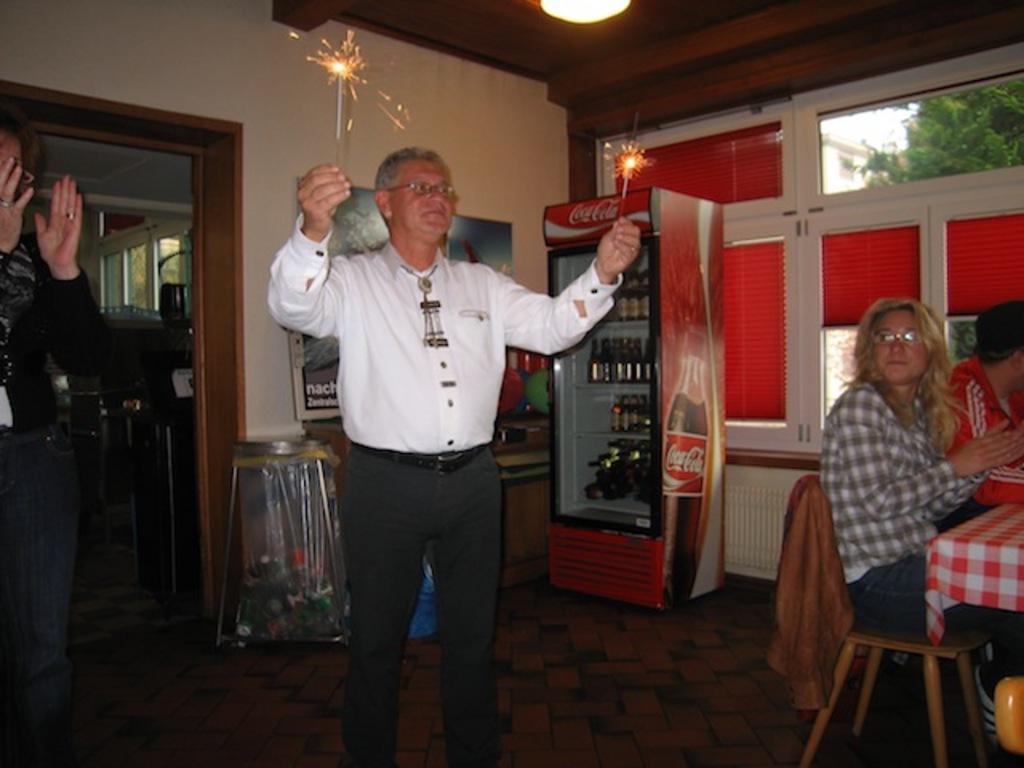Could you give a brief overview of what you see in this image? In this image i can see a man standing holding a cracker at right there are few other man sitting on chair at the back ground i can see few bottles, a window and a wall. 